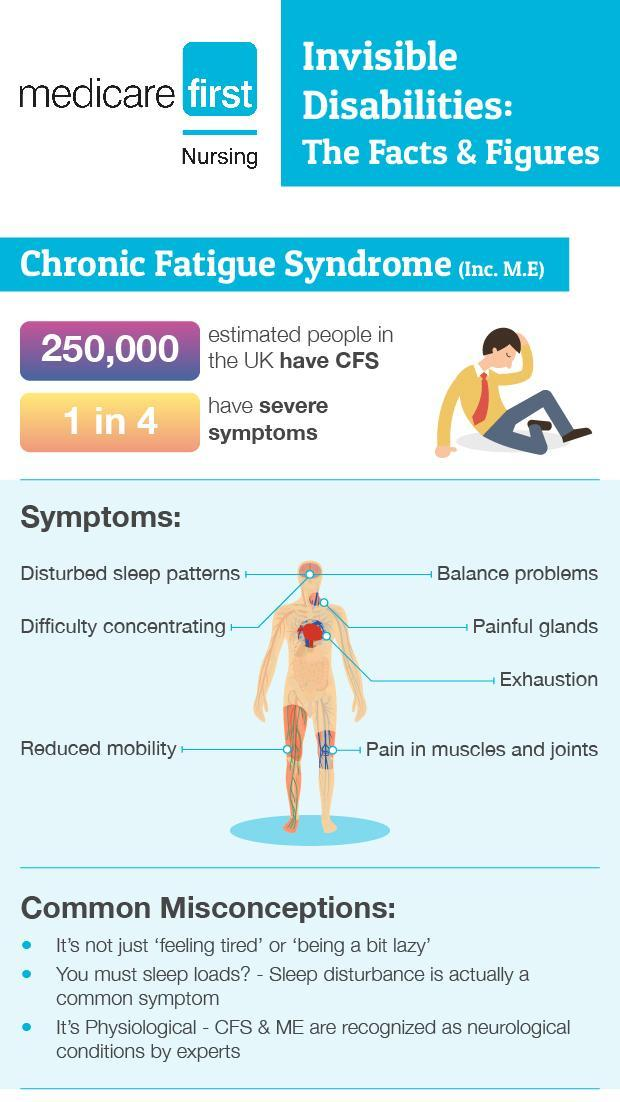What proportion of people do not have severe symptoms?
Answer the question with a short phrase. 3 in 4 